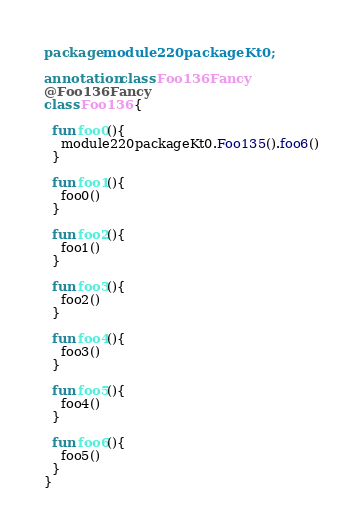<code> <loc_0><loc_0><loc_500><loc_500><_Kotlin_>package module220packageKt0;

annotation class Foo136Fancy
@Foo136Fancy
class Foo136 {

  fun foo0(){
    module220packageKt0.Foo135().foo6()
  }

  fun foo1(){
    foo0()
  }

  fun foo2(){
    foo1()
  }

  fun foo3(){
    foo2()
  }

  fun foo4(){
    foo3()
  }

  fun foo5(){
    foo4()
  }

  fun foo6(){
    foo5()
  }
}</code> 